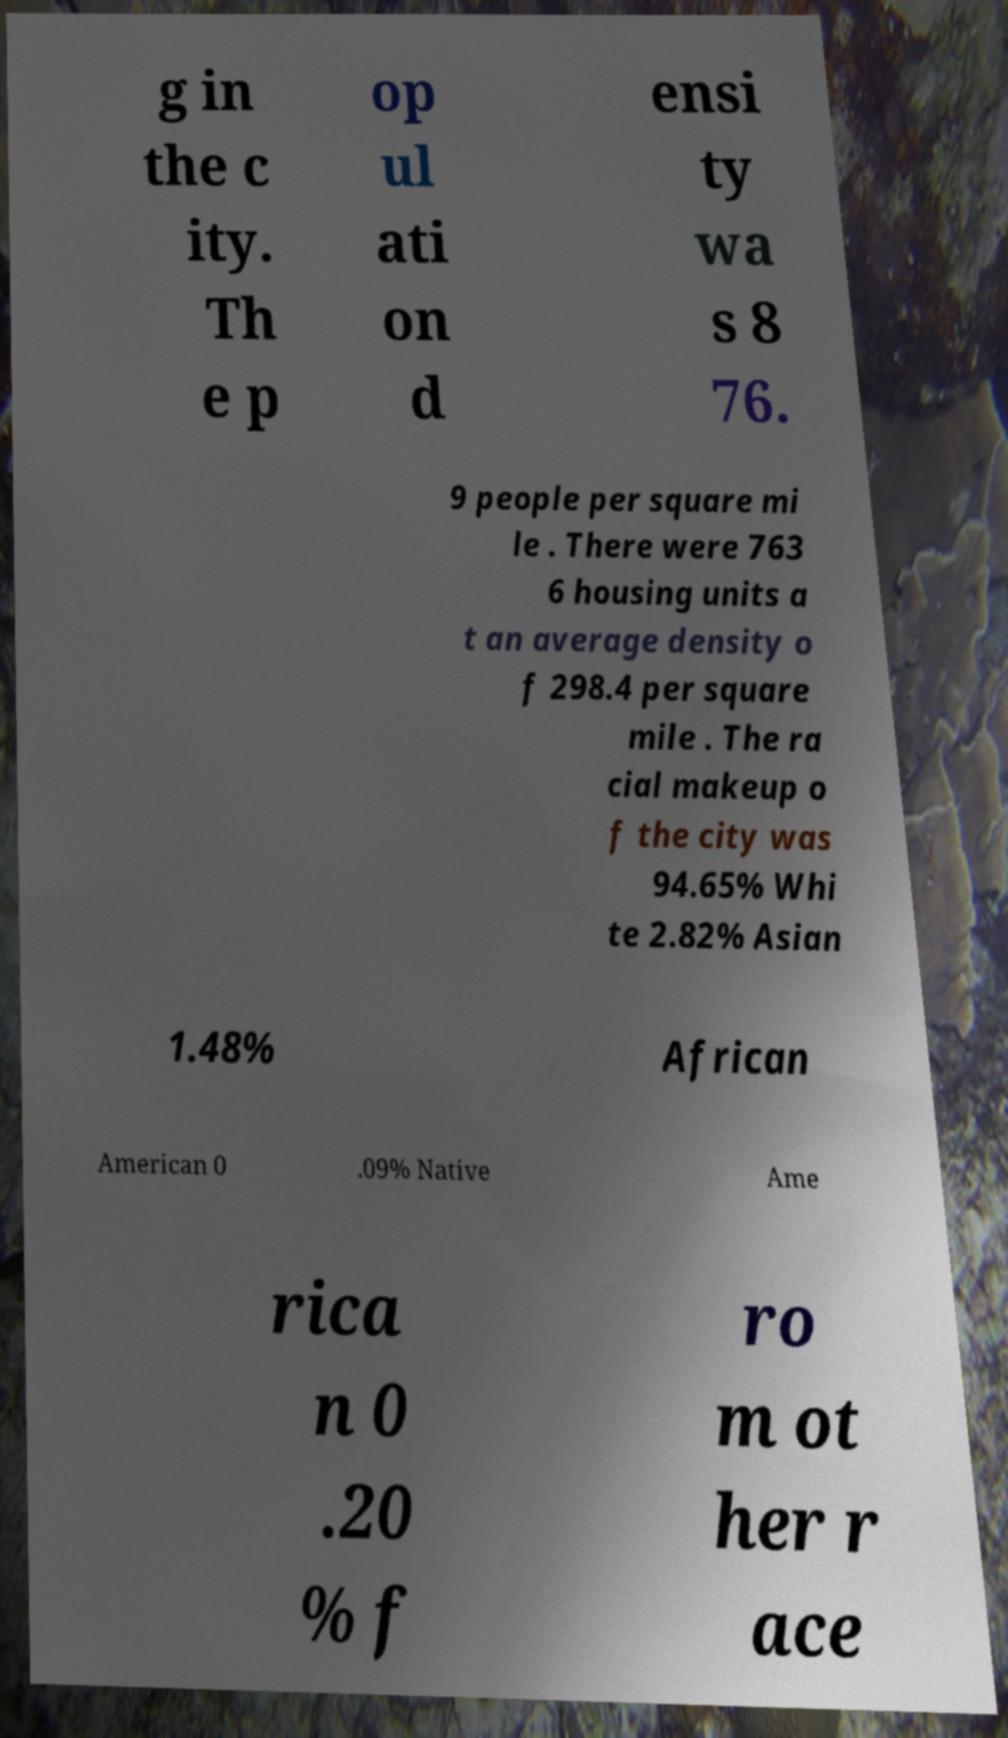What messages or text are displayed in this image? I need them in a readable, typed format. g in the c ity. Th e p op ul ati on d ensi ty wa s 8 76. 9 people per square mi le . There were 763 6 housing units a t an average density o f 298.4 per square mile . The ra cial makeup o f the city was 94.65% Whi te 2.82% Asian 1.48% African American 0 .09% Native Ame rica n 0 .20 % f ro m ot her r ace 